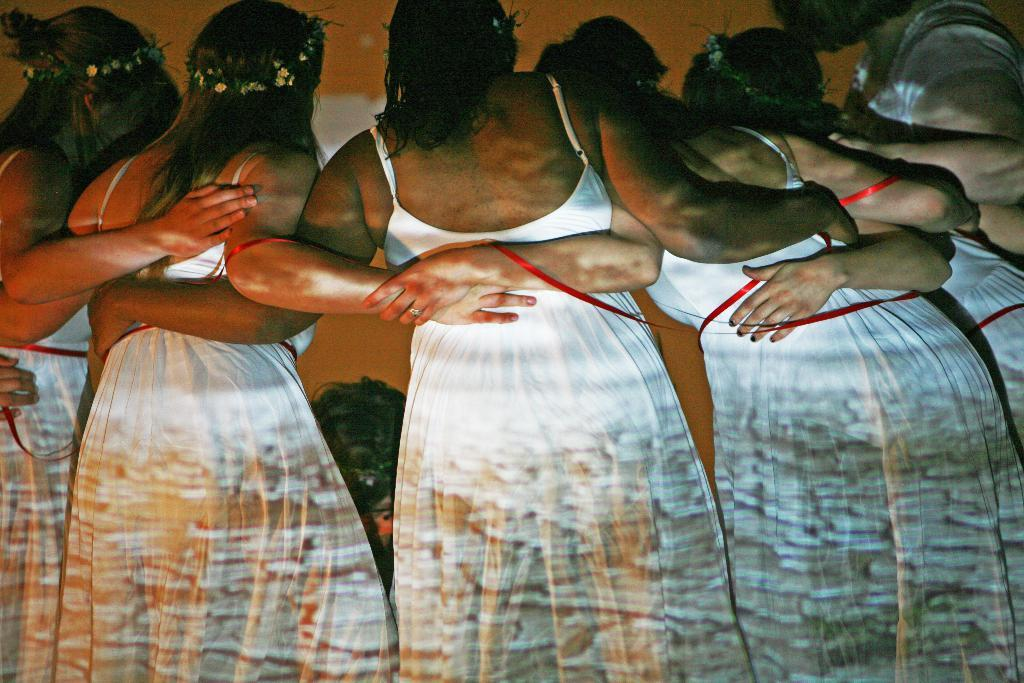How many women are present in the image? There are six women in the image. What are the women doing in the image? The women are standing. What are the women wearing in the image? The women are wearing white dresses. What accessories are the women wearing on their heads? The women have tiaras on their heads. What type of cave can be seen in the background of the image? There is no cave present in the image. What type of lace is used to decorate the women's dresses in the image? The facts do not mention any lace on the women's dresses, so we cannot determine the type of lace used. 